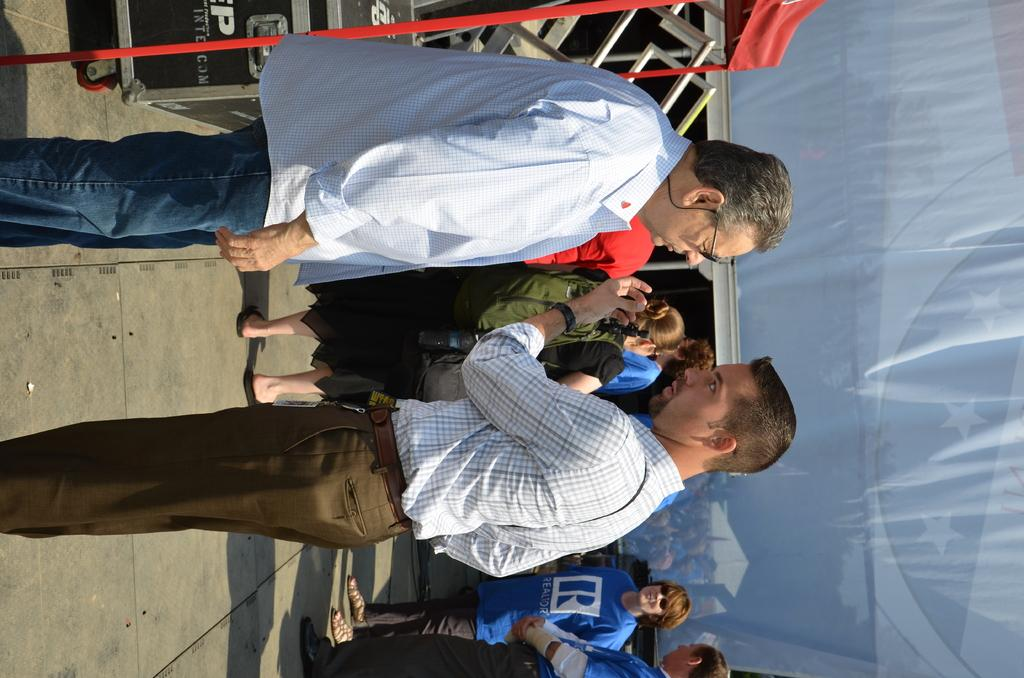Where was the picture taken? The picture was taken outside a city. What can be seen in the foreground of the image? There are many people standing in the foreground of the image. What objects are visible at the top of the image? There are boxes visible at the top of the image. What structure can be seen on the right side of the image? There is a tent on the right side of the image. What topic are the people discussing in the image? There is no information about a discussion or any specific topic being discussed in the image. 